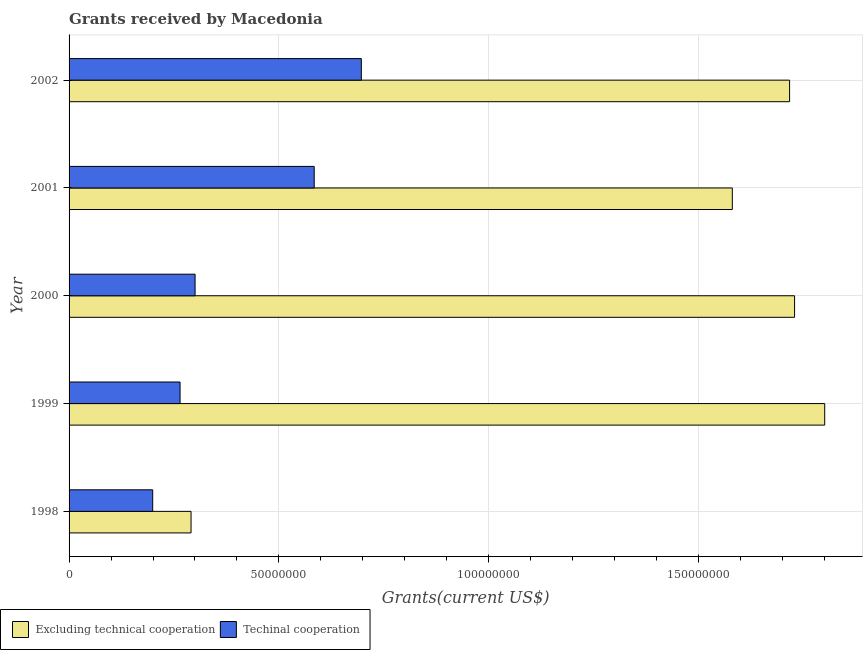Are the number of bars on each tick of the Y-axis equal?
Keep it short and to the point. Yes. How many bars are there on the 4th tick from the bottom?
Give a very brief answer. 2. What is the label of the 4th group of bars from the top?
Give a very brief answer. 1999. In how many cases, is the number of bars for a given year not equal to the number of legend labels?
Keep it short and to the point. 0. What is the amount of grants received(excluding technical cooperation) in 1999?
Give a very brief answer. 1.80e+08. Across all years, what is the maximum amount of grants received(including technical cooperation)?
Offer a terse response. 6.96e+07. Across all years, what is the minimum amount of grants received(excluding technical cooperation)?
Your response must be concise. 2.91e+07. In which year was the amount of grants received(including technical cooperation) maximum?
Provide a short and direct response. 2002. What is the total amount of grants received(including technical cooperation) in the graph?
Provide a succinct answer. 2.04e+08. What is the difference between the amount of grants received(excluding technical cooperation) in 1998 and that in 2001?
Provide a short and direct response. -1.29e+08. What is the difference between the amount of grants received(including technical cooperation) in 2000 and the amount of grants received(excluding technical cooperation) in 2002?
Ensure brevity in your answer.  -1.42e+08. What is the average amount of grants received(excluding technical cooperation) per year?
Your answer should be very brief. 1.42e+08. In the year 1998, what is the difference between the amount of grants received(excluding technical cooperation) and amount of grants received(including technical cooperation)?
Provide a short and direct response. 9.14e+06. What is the ratio of the amount of grants received(excluding technical cooperation) in 2000 to that in 2001?
Your response must be concise. 1.09. Is the amount of grants received(excluding technical cooperation) in 1998 less than that in 2001?
Your response must be concise. Yes. Is the difference between the amount of grants received(excluding technical cooperation) in 1998 and 1999 greater than the difference between the amount of grants received(including technical cooperation) in 1998 and 1999?
Keep it short and to the point. No. What is the difference between the highest and the second highest amount of grants received(excluding technical cooperation)?
Your answer should be very brief. 7.18e+06. What is the difference between the highest and the lowest amount of grants received(excluding technical cooperation)?
Ensure brevity in your answer.  1.51e+08. Is the sum of the amount of grants received(including technical cooperation) in 1999 and 2002 greater than the maximum amount of grants received(excluding technical cooperation) across all years?
Ensure brevity in your answer.  No. What does the 2nd bar from the top in 2000 represents?
Offer a terse response. Excluding technical cooperation. What does the 1st bar from the bottom in 2000 represents?
Your answer should be very brief. Excluding technical cooperation. How many years are there in the graph?
Offer a very short reply. 5. Does the graph contain any zero values?
Keep it short and to the point. No. Does the graph contain grids?
Your answer should be compact. Yes. Where does the legend appear in the graph?
Give a very brief answer. Bottom left. How many legend labels are there?
Your answer should be compact. 2. How are the legend labels stacked?
Offer a very short reply. Horizontal. What is the title of the graph?
Provide a short and direct response. Grants received by Macedonia. Does "From production" appear as one of the legend labels in the graph?
Your response must be concise. No. What is the label or title of the X-axis?
Offer a terse response. Grants(current US$). What is the Grants(current US$) in Excluding technical cooperation in 1998?
Ensure brevity in your answer.  2.91e+07. What is the Grants(current US$) in Techinal cooperation in 1998?
Provide a succinct answer. 1.99e+07. What is the Grants(current US$) of Excluding technical cooperation in 1999?
Your answer should be compact. 1.80e+08. What is the Grants(current US$) of Techinal cooperation in 1999?
Provide a succinct answer. 2.64e+07. What is the Grants(current US$) in Excluding technical cooperation in 2000?
Your answer should be compact. 1.73e+08. What is the Grants(current US$) in Techinal cooperation in 2000?
Keep it short and to the point. 3.00e+07. What is the Grants(current US$) in Excluding technical cooperation in 2001?
Your response must be concise. 1.58e+08. What is the Grants(current US$) of Techinal cooperation in 2001?
Provide a short and direct response. 5.84e+07. What is the Grants(current US$) in Excluding technical cooperation in 2002?
Offer a very short reply. 1.72e+08. What is the Grants(current US$) in Techinal cooperation in 2002?
Offer a terse response. 6.96e+07. Across all years, what is the maximum Grants(current US$) of Excluding technical cooperation?
Provide a short and direct response. 1.80e+08. Across all years, what is the maximum Grants(current US$) of Techinal cooperation?
Your answer should be compact. 6.96e+07. Across all years, what is the minimum Grants(current US$) in Excluding technical cooperation?
Give a very brief answer. 2.91e+07. Across all years, what is the minimum Grants(current US$) in Techinal cooperation?
Provide a succinct answer. 1.99e+07. What is the total Grants(current US$) in Excluding technical cooperation in the graph?
Ensure brevity in your answer.  7.12e+08. What is the total Grants(current US$) in Techinal cooperation in the graph?
Keep it short and to the point. 2.04e+08. What is the difference between the Grants(current US$) of Excluding technical cooperation in 1998 and that in 1999?
Make the answer very short. -1.51e+08. What is the difference between the Grants(current US$) of Techinal cooperation in 1998 and that in 1999?
Make the answer very short. -6.52e+06. What is the difference between the Grants(current US$) in Excluding technical cooperation in 1998 and that in 2000?
Offer a very short reply. -1.44e+08. What is the difference between the Grants(current US$) in Techinal cooperation in 1998 and that in 2000?
Keep it short and to the point. -1.01e+07. What is the difference between the Grants(current US$) in Excluding technical cooperation in 1998 and that in 2001?
Keep it short and to the point. -1.29e+08. What is the difference between the Grants(current US$) of Techinal cooperation in 1998 and that in 2001?
Provide a short and direct response. -3.85e+07. What is the difference between the Grants(current US$) in Excluding technical cooperation in 1998 and that in 2002?
Make the answer very short. -1.43e+08. What is the difference between the Grants(current US$) of Techinal cooperation in 1998 and that in 2002?
Provide a short and direct response. -4.97e+07. What is the difference between the Grants(current US$) in Excluding technical cooperation in 1999 and that in 2000?
Ensure brevity in your answer.  7.18e+06. What is the difference between the Grants(current US$) in Techinal cooperation in 1999 and that in 2000?
Give a very brief answer. -3.58e+06. What is the difference between the Grants(current US$) in Excluding technical cooperation in 1999 and that in 2001?
Provide a short and direct response. 2.20e+07. What is the difference between the Grants(current US$) in Techinal cooperation in 1999 and that in 2001?
Give a very brief answer. -3.20e+07. What is the difference between the Grants(current US$) of Excluding technical cooperation in 1999 and that in 2002?
Your response must be concise. 8.37e+06. What is the difference between the Grants(current US$) of Techinal cooperation in 1999 and that in 2002?
Your response must be concise. -4.32e+07. What is the difference between the Grants(current US$) in Excluding technical cooperation in 2000 and that in 2001?
Keep it short and to the point. 1.48e+07. What is the difference between the Grants(current US$) of Techinal cooperation in 2000 and that in 2001?
Provide a short and direct response. -2.84e+07. What is the difference between the Grants(current US$) of Excluding technical cooperation in 2000 and that in 2002?
Ensure brevity in your answer.  1.19e+06. What is the difference between the Grants(current US$) of Techinal cooperation in 2000 and that in 2002?
Provide a succinct answer. -3.96e+07. What is the difference between the Grants(current US$) of Excluding technical cooperation in 2001 and that in 2002?
Your answer should be compact. -1.36e+07. What is the difference between the Grants(current US$) in Techinal cooperation in 2001 and that in 2002?
Make the answer very short. -1.12e+07. What is the difference between the Grants(current US$) of Excluding technical cooperation in 1998 and the Grants(current US$) of Techinal cooperation in 1999?
Provide a short and direct response. 2.62e+06. What is the difference between the Grants(current US$) of Excluding technical cooperation in 1998 and the Grants(current US$) of Techinal cooperation in 2000?
Offer a very short reply. -9.60e+05. What is the difference between the Grants(current US$) in Excluding technical cooperation in 1998 and the Grants(current US$) in Techinal cooperation in 2001?
Give a very brief answer. -2.94e+07. What is the difference between the Grants(current US$) of Excluding technical cooperation in 1998 and the Grants(current US$) of Techinal cooperation in 2002?
Give a very brief answer. -4.06e+07. What is the difference between the Grants(current US$) of Excluding technical cooperation in 1999 and the Grants(current US$) of Techinal cooperation in 2000?
Offer a very short reply. 1.50e+08. What is the difference between the Grants(current US$) in Excluding technical cooperation in 1999 and the Grants(current US$) in Techinal cooperation in 2001?
Your response must be concise. 1.22e+08. What is the difference between the Grants(current US$) in Excluding technical cooperation in 1999 and the Grants(current US$) in Techinal cooperation in 2002?
Your response must be concise. 1.10e+08. What is the difference between the Grants(current US$) of Excluding technical cooperation in 2000 and the Grants(current US$) of Techinal cooperation in 2001?
Ensure brevity in your answer.  1.14e+08. What is the difference between the Grants(current US$) of Excluding technical cooperation in 2000 and the Grants(current US$) of Techinal cooperation in 2002?
Provide a short and direct response. 1.03e+08. What is the difference between the Grants(current US$) of Excluding technical cooperation in 2001 and the Grants(current US$) of Techinal cooperation in 2002?
Ensure brevity in your answer.  8.84e+07. What is the average Grants(current US$) of Excluding technical cooperation per year?
Your response must be concise. 1.42e+08. What is the average Grants(current US$) in Techinal cooperation per year?
Your answer should be compact. 4.09e+07. In the year 1998, what is the difference between the Grants(current US$) in Excluding technical cooperation and Grants(current US$) in Techinal cooperation?
Your response must be concise. 9.14e+06. In the year 1999, what is the difference between the Grants(current US$) of Excluding technical cooperation and Grants(current US$) of Techinal cooperation?
Your answer should be compact. 1.54e+08. In the year 2000, what is the difference between the Grants(current US$) in Excluding technical cooperation and Grants(current US$) in Techinal cooperation?
Provide a short and direct response. 1.43e+08. In the year 2001, what is the difference between the Grants(current US$) in Excluding technical cooperation and Grants(current US$) in Techinal cooperation?
Give a very brief answer. 9.96e+07. In the year 2002, what is the difference between the Grants(current US$) in Excluding technical cooperation and Grants(current US$) in Techinal cooperation?
Your response must be concise. 1.02e+08. What is the ratio of the Grants(current US$) in Excluding technical cooperation in 1998 to that in 1999?
Your response must be concise. 0.16. What is the ratio of the Grants(current US$) in Techinal cooperation in 1998 to that in 1999?
Provide a succinct answer. 0.75. What is the ratio of the Grants(current US$) of Excluding technical cooperation in 1998 to that in 2000?
Make the answer very short. 0.17. What is the ratio of the Grants(current US$) in Techinal cooperation in 1998 to that in 2000?
Keep it short and to the point. 0.66. What is the ratio of the Grants(current US$) in Excluding technical cooperation in 1998 to that in 2001?
Keep it short and to the point. 0.18. What is the ratio of the Grants(current US$) of Techinal cooperation in 1998 to that in 2001?
Offer a terse response. 0.34. What is the ratio of the Grants(current US$) in Excluding technical cooperation in 1998 to that in 2002?
Provide a short and direct response. 0.17. What is the ratio of the Grants(current US$) of Techinal cooperation in 1998 to that in 2002?
Keep it short and to the point. 0.29. What is the ratio of the Grants(current US$) in Excluding technical cooperation in 1999 to that in 2000?
Keep it short and to the point. 1.04. What is the ratio of the Grants(current US$) of Techinal cooperation in 1999 to that in 2000?
Make the answer very short. 0.88. What is the ratio of the Grants(current US$) in Excluding technical cooperation in 1999 to that in 2001?
Your response must be concise. 1.14. What is the ratio of the Grants(current US$) in Techinal cooperation in 1999 to that in 2001?
Offer a terse response. 0.45. What is the ratio of the Grants(current US$) of Excluding technical cooperation in 1999 to that in 2002?
Your answer should be very brief. 1.05. What is the ratio of the Grants(current US$) of Techinal cooperation in 1999 to that in 2002?
Provide a succinct answer. 0.38. What is the ratio of the Grants(current US$) in Excluding technical cooperation in 2000 to that in 2001?
Your answer should be compact. 1.09. What is the ratio of the Grants(current US$) in Techinal cooperation in 2000 to that in 2001?
Your answer should be compact. 0.51. What is the ratio of the Grants(current US$) of Excluding technical cooperation in 2000 to that in 2002?
Provide a succinct answer. 1.01. What is the ratio of the Grants(current US$) in Techinal cooperation in 2000 to that in 2002?
Your response must be concise. 0.43. What is the ratio of the Grants(current US$) in Excluding technical cooperation in 2001 to that in 2002?
Provide a short and direct response. 0.92. What is the ratio of the Grants(current US$) of Techinal cooperation in 2001 to that in 2002?
Give a very brief answer. 0.84. What is the difference between the highest and the second highest Grants(current US$) of Excluding technical cooperation?
Provide a short and direct response. 7.18e+06. What is the difference between the highest and the second highest Grants(current US$) of Techinal cooperation?
Offer a terse response. 1.12e+07. What is the difference between the highest and the lowest Grants(current US$) in Excluding technical cooperation?
Give a very brief answer. 1.51e+08. What is the difference between the highest and the lowest Grants(current US$) of Techinal cooperation?
Keep it short and to the point. 4.97e+07. 